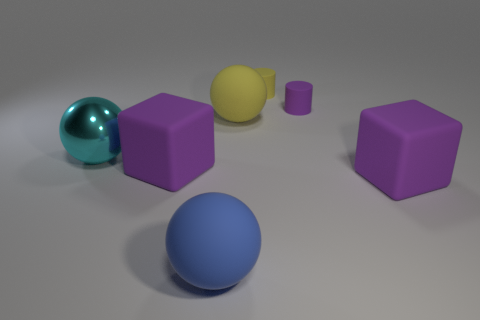What are the objects in the image and how many are there? The image contains six objects in total: two spheres, two cubes, and two cylinders. The objects vary in color and appear to have either a matte or shiny surface. 